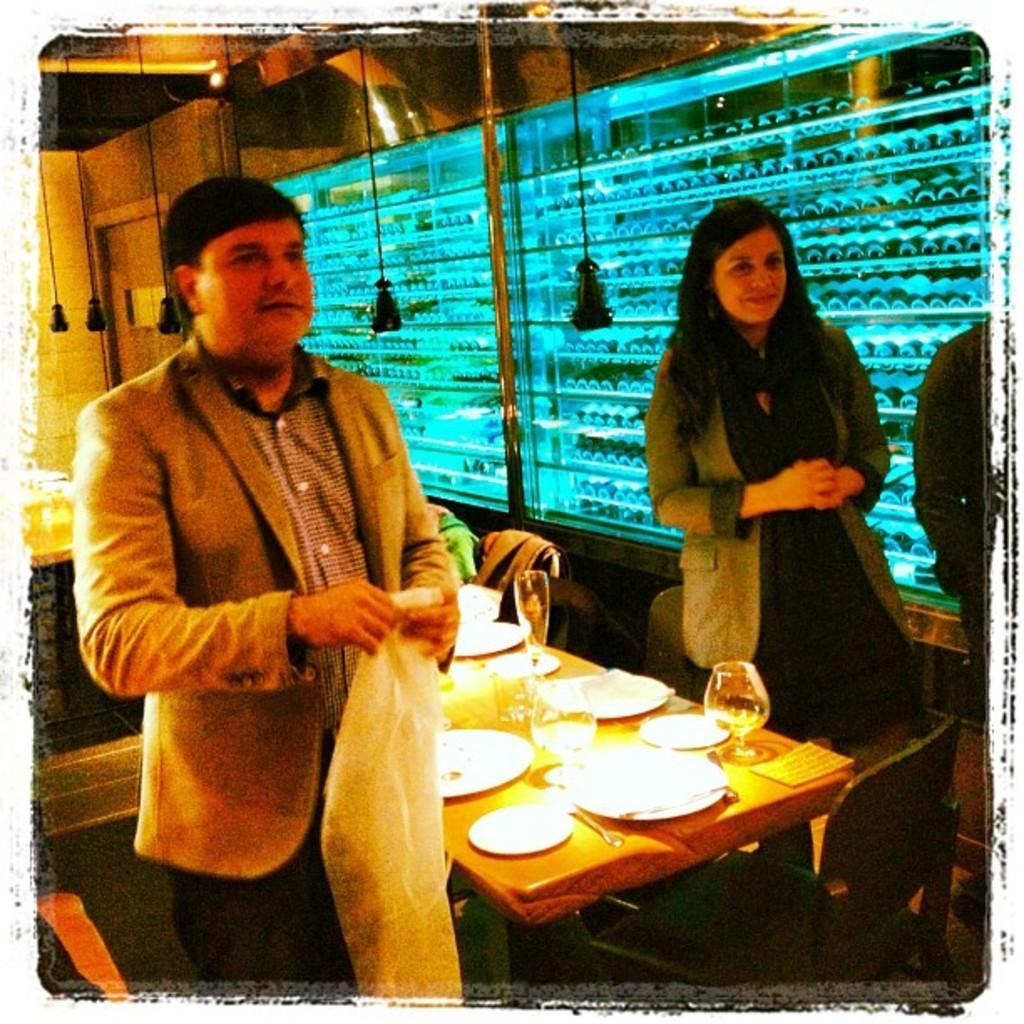Describe this image in one or two sentences. In this picture there is a man and a woman on either side of the table on which plates, glasses, tissues were placed. In the background there is a window and a wall here. 